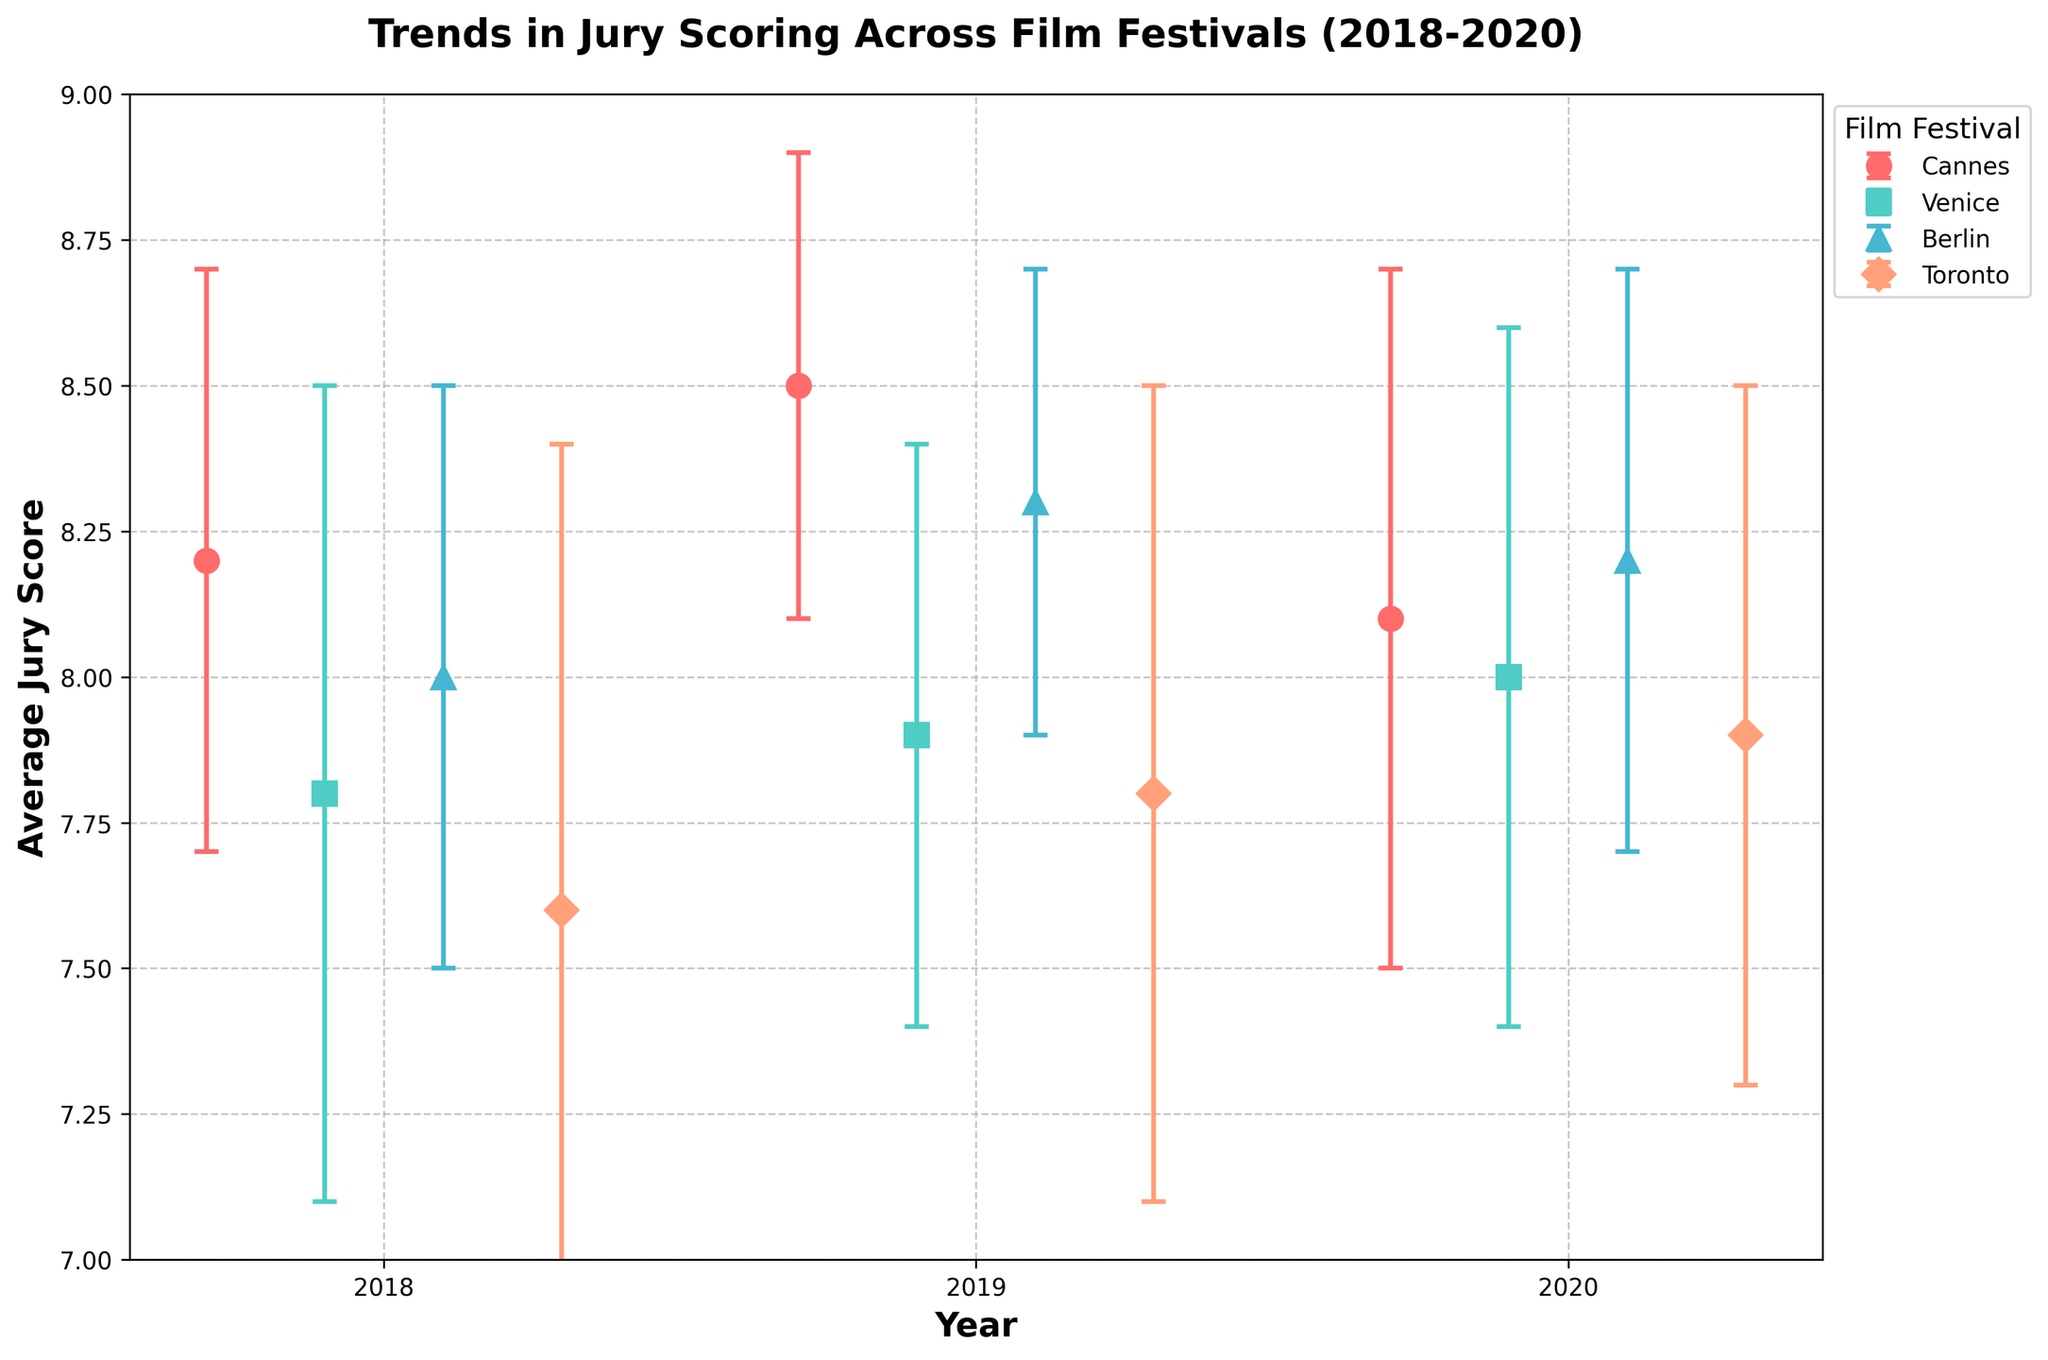What is the average jury score for Cannes in 2018? The figure shows error bars for each festival and year, with the average jury scores indicated by markers. Locate the marker for Cannes in 2018 and note its value.
Answer: 8.2 Which festival had the highest average jury score in 2019? Compare the markers for all festivals in 2019. The highest average jury score marker will indicate the festival.
Answer: Cannes What is the range of the error bars for Berlin in 2020? Identify the error bar for Berlin in 2020 on the graph. The range is from (average score - error) to (average score + error).
Answer: 7.7 to 8.7 Which festival had the lowest average jury score in 2018? Locate the markers for all festivals in 2018 and compare their values. The lowest marker indicates the festival.
Answer: Toronto How did the average jury score for Venice change from 2018 to 2020? Identify Venice's markers from 2018, 2019, and 2020. Calculate the difference in scores between each consecutive year.
Answer: Increased by 0.2 (7.8 to 8.0) What is the approximate average of the jury scores for all festivals in 2019? Sum the average jury scores for all festivals in 2019 and divide by the number of festivals (4). (8.5 + 7.9 + 8.3 + 7.8)/4 = 8.125
Answer: 8.125 Which festival shows the largest spread in jury scores in 2018 based on error bars? Compare the length of all error bars for 2018. The largest error bar indicates the largest spread.
Answer: Toronto In which year did Cannes experience the highest standard deviation in jury scores? Compare the error bars for Cannes across all years and identify the longest one, which indicates the highest standard deviation.
Answer: 2020 Did any festival show a consistent trend (either increasing or decreasing) in average jury scores over the three years? Examine the markers for each festival from 2018 to 2020 and determine if the average scores steadily increased or decreased. Only Toronto shows a consistent increase.
Answer: Toronto 